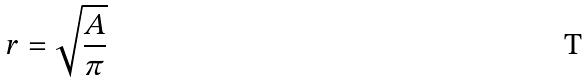Convert formula to latex. <formula><loc_0><loc_0><loc_500><loc_500>r = \sqrt { \frac { A } { \pi } }</formula> 